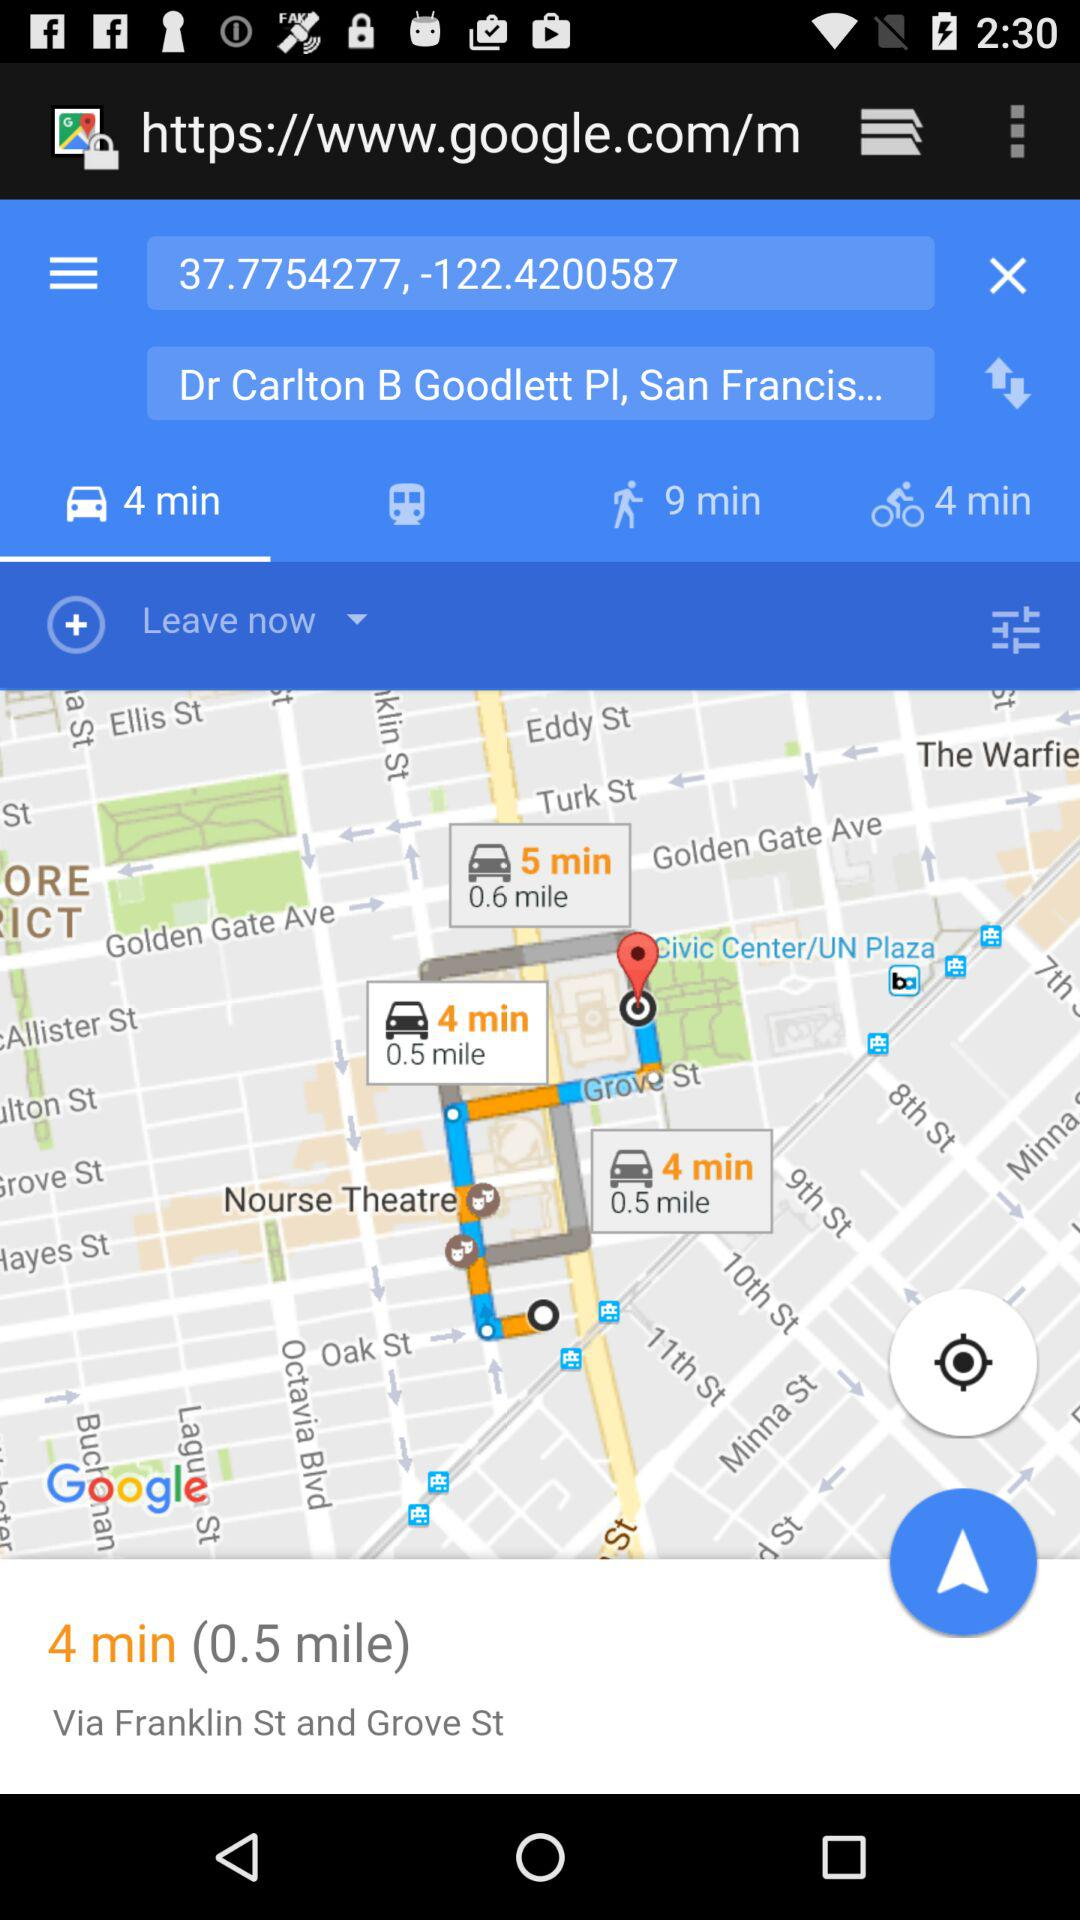What is the distance that is displayed on the screen? The distance that is displayed on the screen is 0.5 miles. 